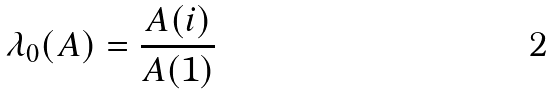Convert formula to latex. <formula><loc_0><loc_0><loc_500><loc_500>\lambda _ { 0 } ( A ) = \frac { A ( i ) } { A ( 1 ) }</formula> 